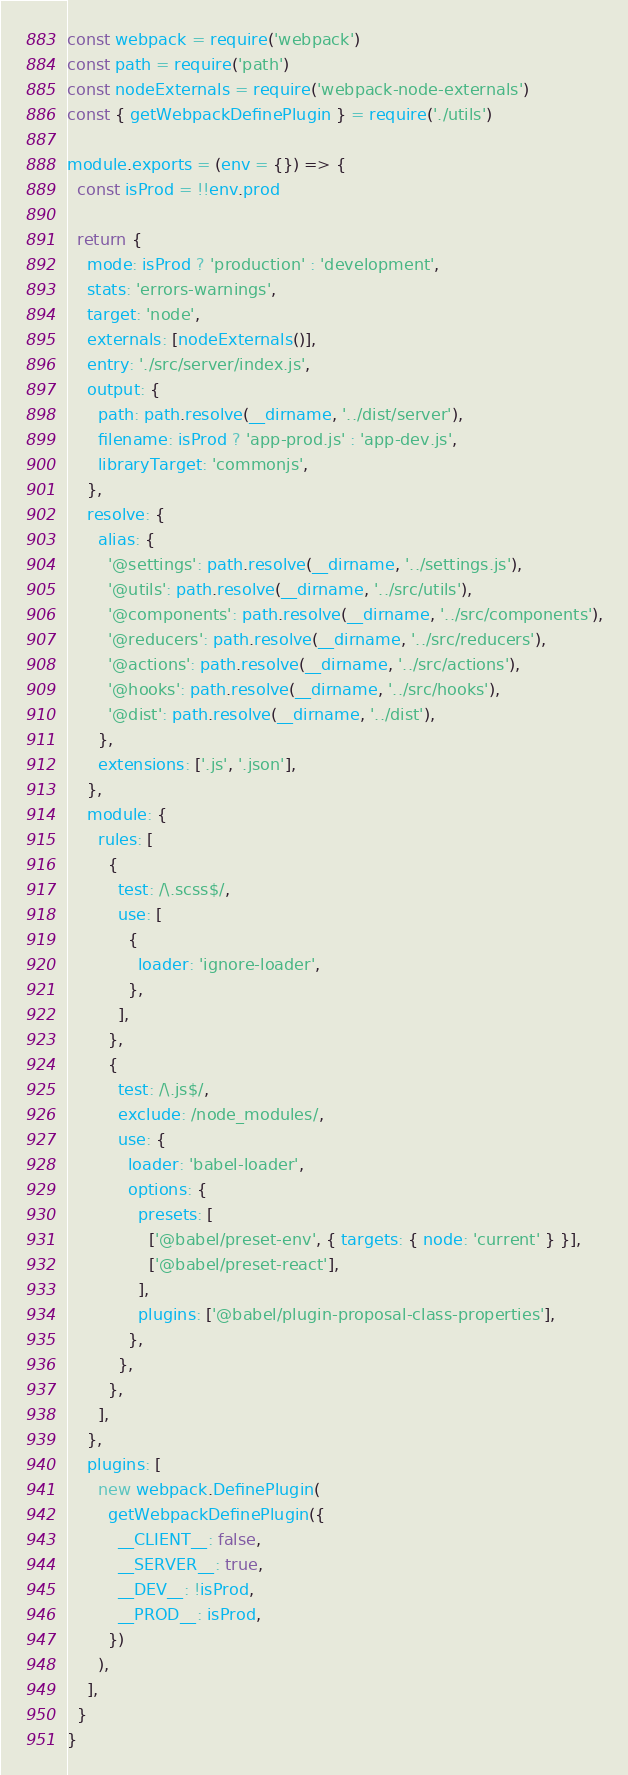<code> <loc_0><loc_0><loc_500><loc_500><_JavaScript_>const webpack = require('webpack')
const path = require('path')
const nodeExternals = require('webpack-node-externals')
const { getWebpackDefinePlugin } = require('./utils')

module.exports = (env = {}) => {
  const isProd = !!env.prod

  return {
    mode: isProd ? 'production' : 'development',
    stats: 'errors-warnings',
    target: 'node',
    externals: [nodeExternals()],
    entry: './src/server/index.js',
    output: {
      path: path.resolve(__dirname, '../dist/server'),
      filename: isProd ? 'app-prod.js' : 'app-dev.js',
      libraryTarget: 'commonjs',
    },
    resolve: {
      alias: {
        '@settings': path.resolve(__dirname, '../settings.js'),
        '@utils': path.resolve(__dirname, '../src/utils'),
        '@components': path.resolve(__dirname, '../src/components'),
        '@reducers': path.resolve(__dirname, '../src/reducers'),
        '@actions': path.resolve(__dirname, '../src/actions'),
        '@hooks': path.resolve(__dirname, '../src/hooks'),
        '@dist': path.resolve(__dirname, '../dist'),
      },
      extensions: ['.js', '.json'],
    },
    module: {
      rules: [
        {
          test: /\.scss$/,
          use: [
            {
              loader: 'ignore-loader',
            },
          ],
        },
        {
          test: /\.js$/,
          exclude: /node_modules/,
          use: {
            loader: 'babel-loader',
            options: {
              presets: [
                ['@babel/preset-env', { targets: { node: 'current' } }],
                ['@babel/preset-react'],
              ],
              plugins: ['@babel/plugin-proposal-class-properties'],
            },
          },
        },
      ],
    },
    plugins: [
      new webpack.DefinePlugin(
        getWebpackDefinePlugin({
          __CLIENT__: false,
          __SERVER__: true,
          __DEV__: !isProd,
          __PROD__: isProd,
        })
      ),
    ],
  }
}
</code> 